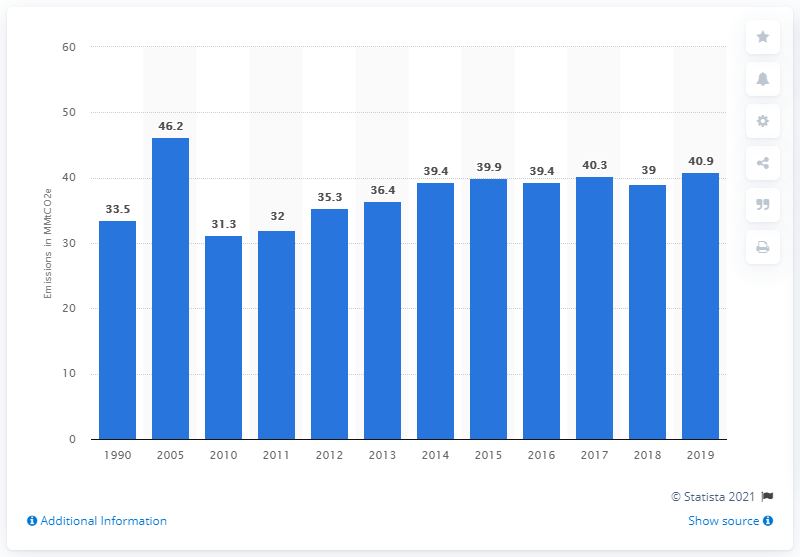Indicate a few pertinent items in this graphic. In 2019, the United States produced approximately 40.9 million metric tons of carbon dioxide equivalent through the production of cement. 